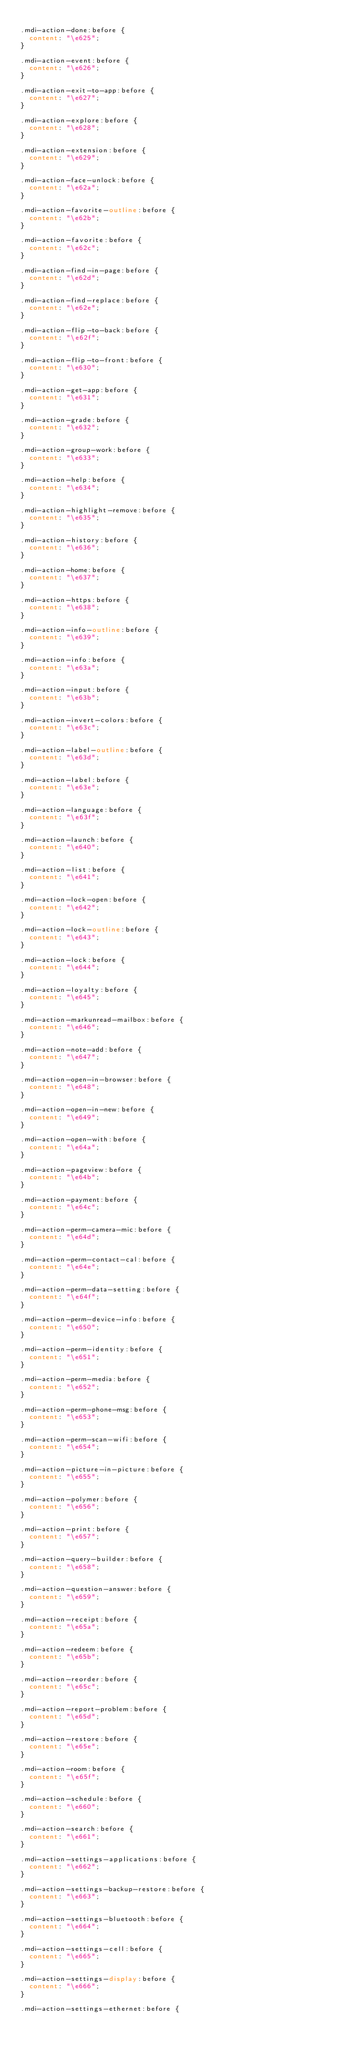<code> <loc_0><loc_0><loc_500><loc_500><_CSS_>
.mdi-action-done:before {
  content: "\e625";
}

.mdi-action-event:before {
  content: "\e626";
}

.mdi-action-exit-to-app:before {
  content: "\e627";
}

.mdi-action-explore:before {
  content: "\e628";
}

.mdi-action-extension:before {
  content: "\e629";
}

.mdi-action-face-unlock:before {
  content: "\e62a";
}

.mdi-action-favorite-outline:before {
  content: "\e62b";
}

.mdi-action-favorite:before {
  content: "\e62c";
}

.mdi-action-find-in-page:before {
  content: "\e62d";
}

.mdi-action-find-replace:before {
  content: "\e62e";
}

.mdi-action-flip-to-back:before {
  content: "\e62f";
}

.mdi-action-flip-to-front:before {
  content: "\e630";
}

.mdi-action-get-app:before {
  content: "\e631";
}

.mdi-action-grade:before {
  content: "\e632";
}

.mdi-action-group-work:before {
  content: "\e633";
}

.mdi-action-help:before {
  content: "\e634";
}

.mdi-action-highlight-remove:before {
  content: "\e635";
}

.mdi-action-history:before {
  content: "\e636";
}

.mdi-action-home:before {
  content: "\e637";
}

.mdi-action-https:before {
  content: "\e638";
}

.mdi-action-info-outline:before {
  content: "\e639";
}

.mdi-action-info:before {
  content: "\e63a";
}

.mdi-action-input:before {
  content: "\e63b";
}

.mdi-action-invert-colors:before {
  content: "\e63c";
}

.mdi-action-label-outline:before {
  content: "\e63d";
}

.mdi-action-label:before {
  content: "\e63e";
}

.mdi-action-language:before {
  content: "\e63f";
}

.mdi-action-launch:before {
  content: "\e640";
}

.mdi-action-list:before {
  content: "\e641";
}

.mdi-action-lock-open:before {
  content: "\e642";
}

.mdi-action-lock-outline:before {
  content: "\e643";
}

.mdi-action-lock:before {
  content: "\e644";
}

.mdi-action-loyalty:before {
  content: "\e645";
}

.mdi-action-markunread-mailbox:before {
  content: "\e646";
}

.mdi-action-note-add:before {
  content: "\e647";
}

.mdi-action-open-in-browser:before {
  content: "\e648";
}

.mdi-action-open-in-new:before {
  content: "\e649";
}

.mdi-action-open-with:before {
  content: "\e64a";
}

.mdi-action-pageview:before {
  content: "\e64b";
}

.mdi-action-payment:before {
  content: "\e64c";
}

.mdi-action-perm-camera-mic:before {
  content: "\e64d";
}

.mdi-action-perm-contact-cal:before {
  content: "\e64e";
}

.mdi-action-perm-data-setting:before {
  content: "\e64f";
}

.mdi-action-perm-device-info:before {
  content: "\e650";
}

.mdi-action-perm-identity:before {
  content: "\e651";
}

.mdi-action-perm-media:before {
  content: "\e652";
}

.mdi-action-perm-phone-msg:before {
  content: "\e653";
}

.mdi-action-perm-scan-wifi:before {
  content: "\e654";
}

.mdi-action-picture-in-picture:before {
  content: "\e655";
}

.mdi-action-polymer:before {
  content: "\e656";
}

.mdi-action-print:before {
  content: "\e657";
}

.mdi-action-query-builder:before {
  content: "\e658";
}

.mdi-action-question-answer:before {
  content: "\e659";
}

.mdi-action-receipt:before {
  content: "\e65a";
}

.mdi-action-redeem:before {
  content: "\e65b";
}

.mdi-action-reorder:before {
  content: "\e65c";
}

.mdi-action-report-problem:before {
  content: "\e65d";
}

.mdi-action-restore:before {
  content: "\e65e";
}

.mdi-action-room:before {
  content: "\e65f";
}

.mdi-action-schedule:before {
  content: "\e660";
}

.mdi-action-search:before {
  content: "\e661";
}

.mdi-action-settings-applications:before {
  content: "\e662";
}

.mdi-action-settings-backup-restore:before {
  content: "\e663";
}

.mdi-action-settings-bluetooth:before {
  content: "\e664";
}

.mdi-action-settings-cell:before {
  content: "\e665";
}

.mdi-action-settings-display:before {
  content: "\e666";
}

.mdi-action-settings-ethernet:before {</code> 